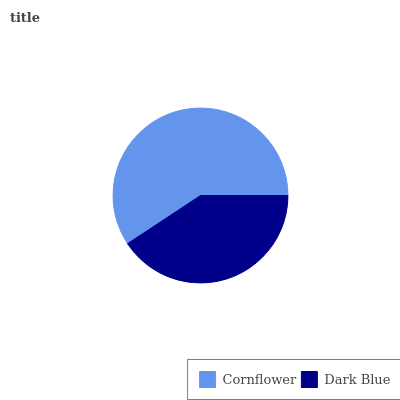Is Dark Blue the minimum?
Answer yes or no. Yes. Is Cornflower the maximum?
Answer yes or no. Yes. Is Dark Blue the maximum?
Answer yes or no. No. Is Cornflower greater than Dark Blue?
Answer yes or no. Yes. Is Dark Blue less than Cornflower?
Answer yes or no. Yes. Is Dark Blue greater than Cornflower?
Answer yes or no. No. Is Cornflower less than Dark Blue?
Answer yes or no. No. Is Cornflower the high median?
Answer yes or no. Yes. Is Dark Blue the low median?
Answer yes or no. Yes. Is Dark Blue the high median?
Answer yes or no. No. Is Cornflower the low median?
Answer yes or no. No. 